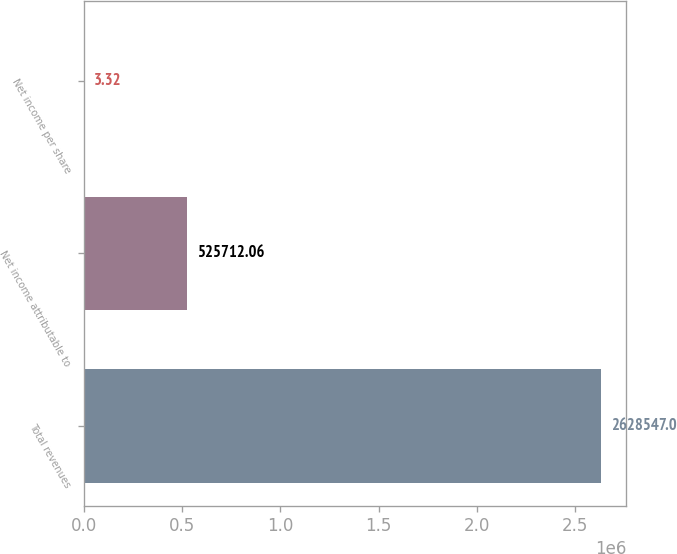Convert chart. <chart><loc_0><loc_0><loc_500><loc_500><bar_chart><fcel>Total revenues<fcel>Net income attributable to<fcel>Net income per share<nl><fcel>2.62855e+06<fcel>525712<fcel>3.32<nl></chart> 